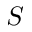<formula> <loc_0><loc_0><loc_500><loc_500>S</formula> 